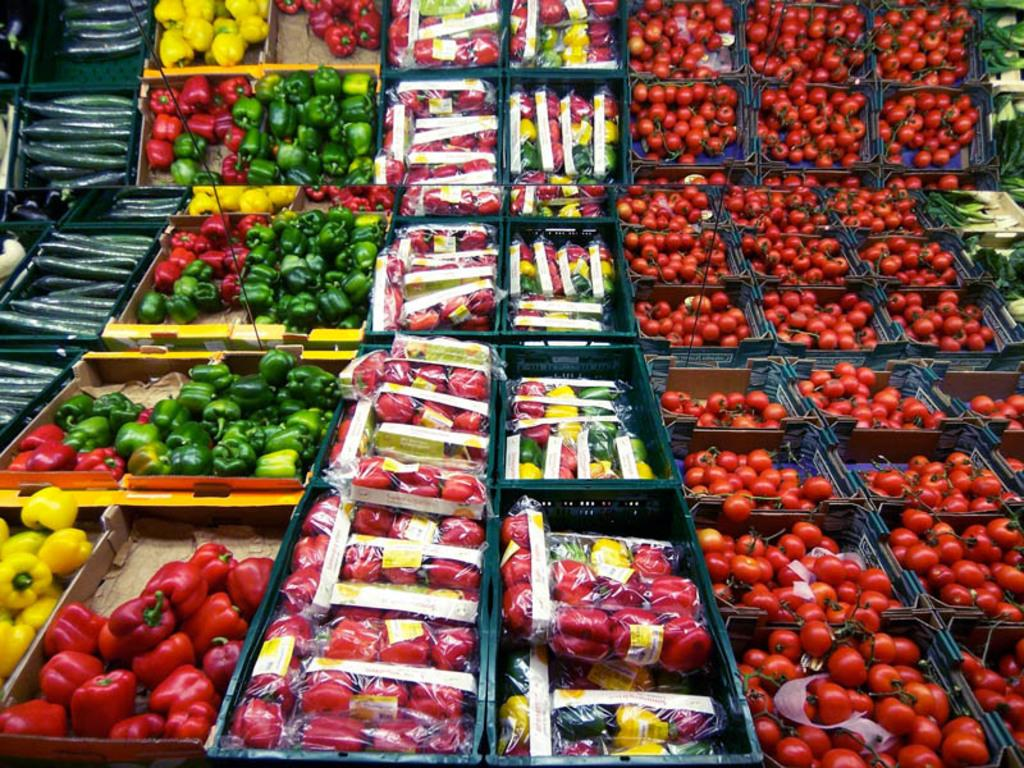What objects are present in the image? There are baskets in the image. What are the baskets used for? The baskets contain vegetables. What type of sweater is draped over the net in the image? There is no sweater or net present in the image; it only contains baskets with vegetables. 